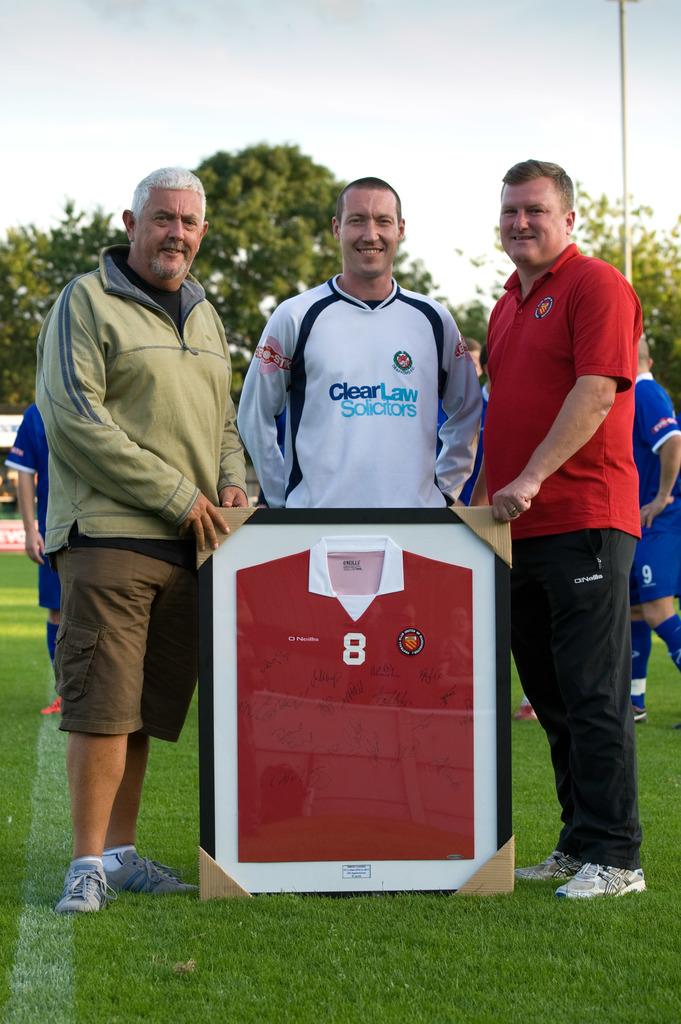What number is on the jersey?
Ensure brevity in your answer.  8. 